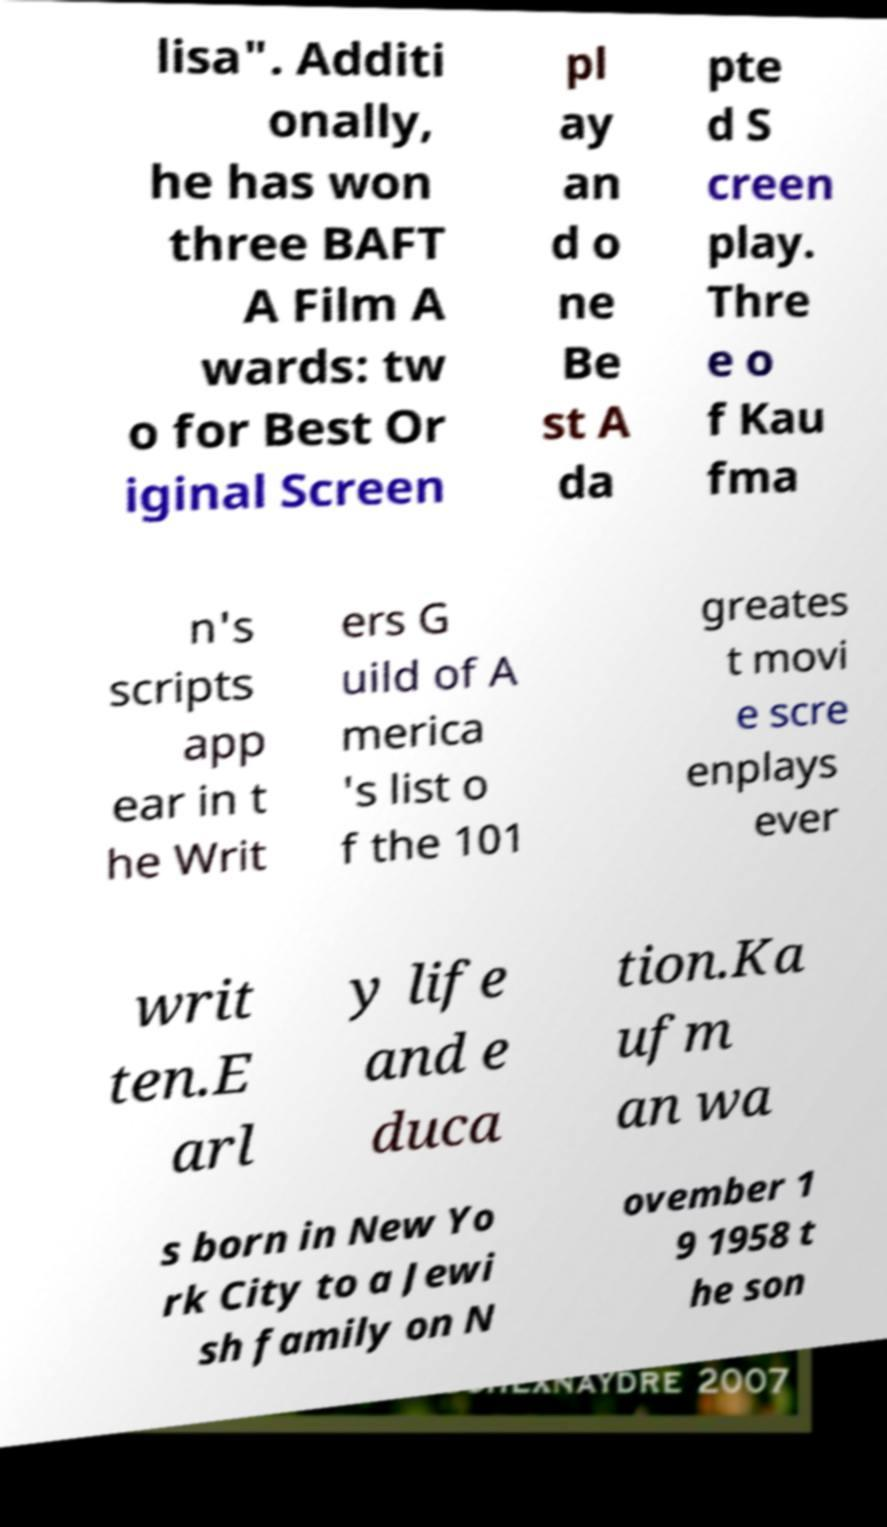Can you accurately transcribe the text from the provided image for me? lisa". Additi onally, he has won three BAFT A Film A wards: tw o for Best Or iginal Screen pl ay an d o ne Be st A da pte d S creen play. Thre e o f Kau fma n's scripts app ear in t he Writ ers G uild of A merica 's list o f the 101 greates t movi e scre enplays ever writ ten.E arl y life and e duca tion.Ka ufm an wa s born in New Yo rk City to a Jewi sh family on N ovember 1 9 1958 t he son 